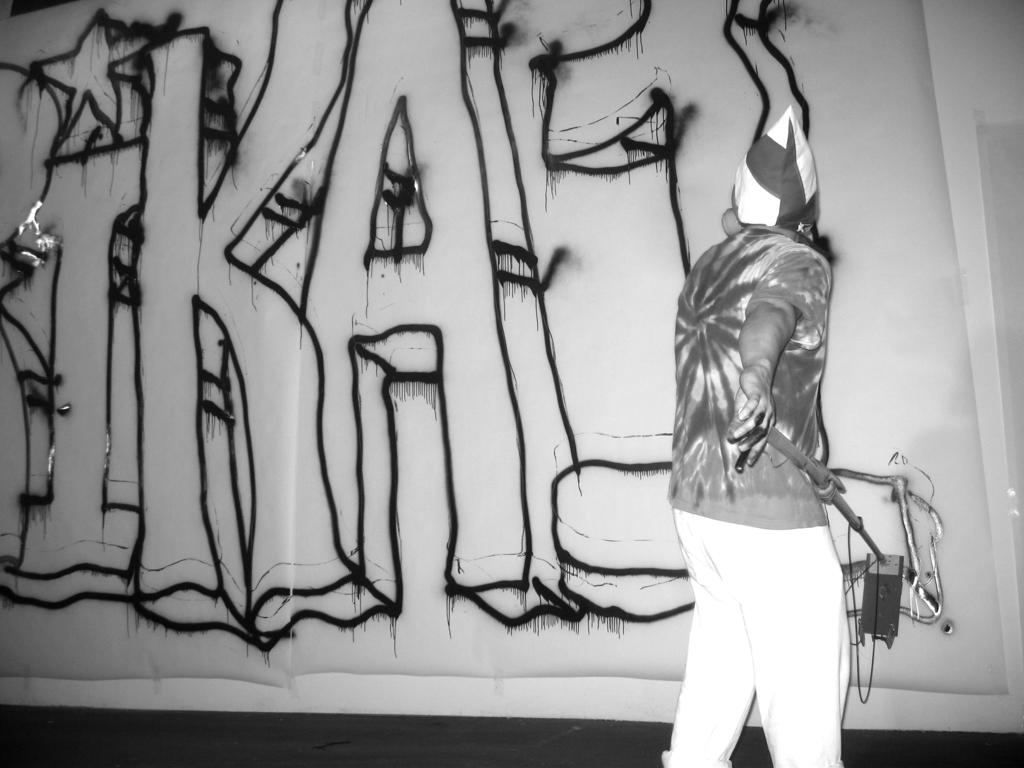What is the person in the image doing? The person is standing in the image. What is the person holding in the image? The person is holding something. What can be seen in the background of the image? There is a wall in the image. What is written on the wall? Something is written on the wall. How is the image presented in terms of color? The image is in black and white. What type of dress is the person wearing in the image? The image is in black and white, so it is not possible to determine the type of dress the person is wearing. Additionally, the provided facts do not mention a dress. 